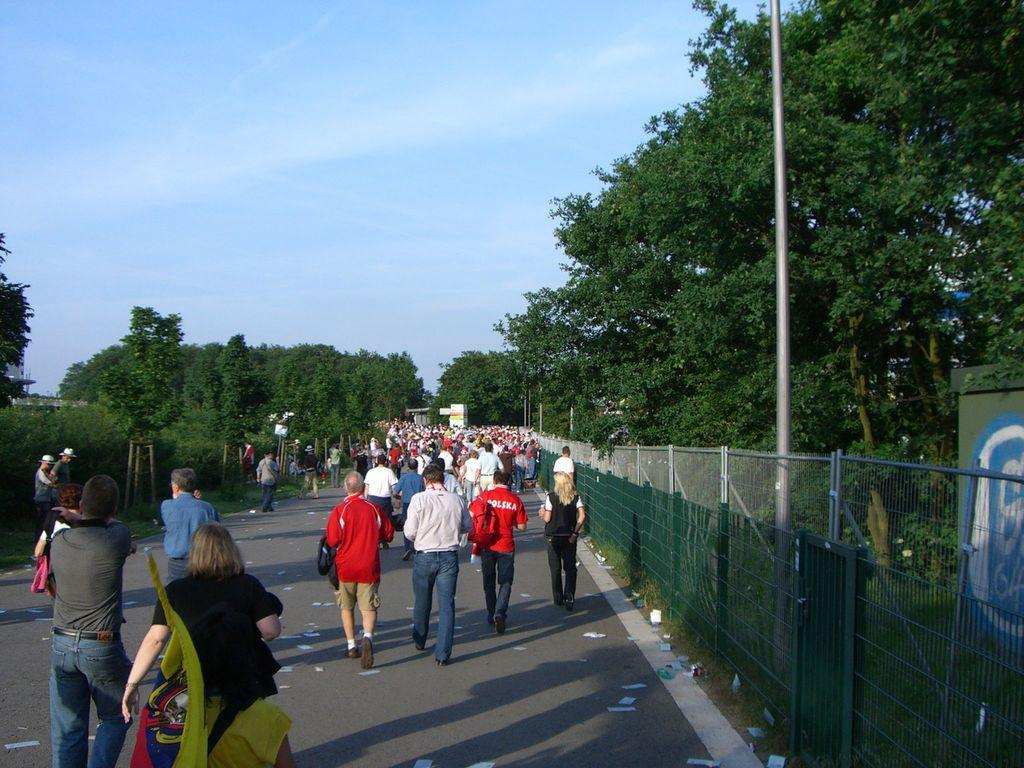What is the main feature of the image? There is a road in the image. What are the people in the image doing? There are people walking on the road. What is located on the right side of the image? There is a fence on the right side of the image. What type of vegetation can be seen in the image? There are green trees visible in the image. What color is the sky in the image? The sky is blue in the image. What type of story is being told by the finger in the image? There is no finger present in the image, so no story can be told by it. 